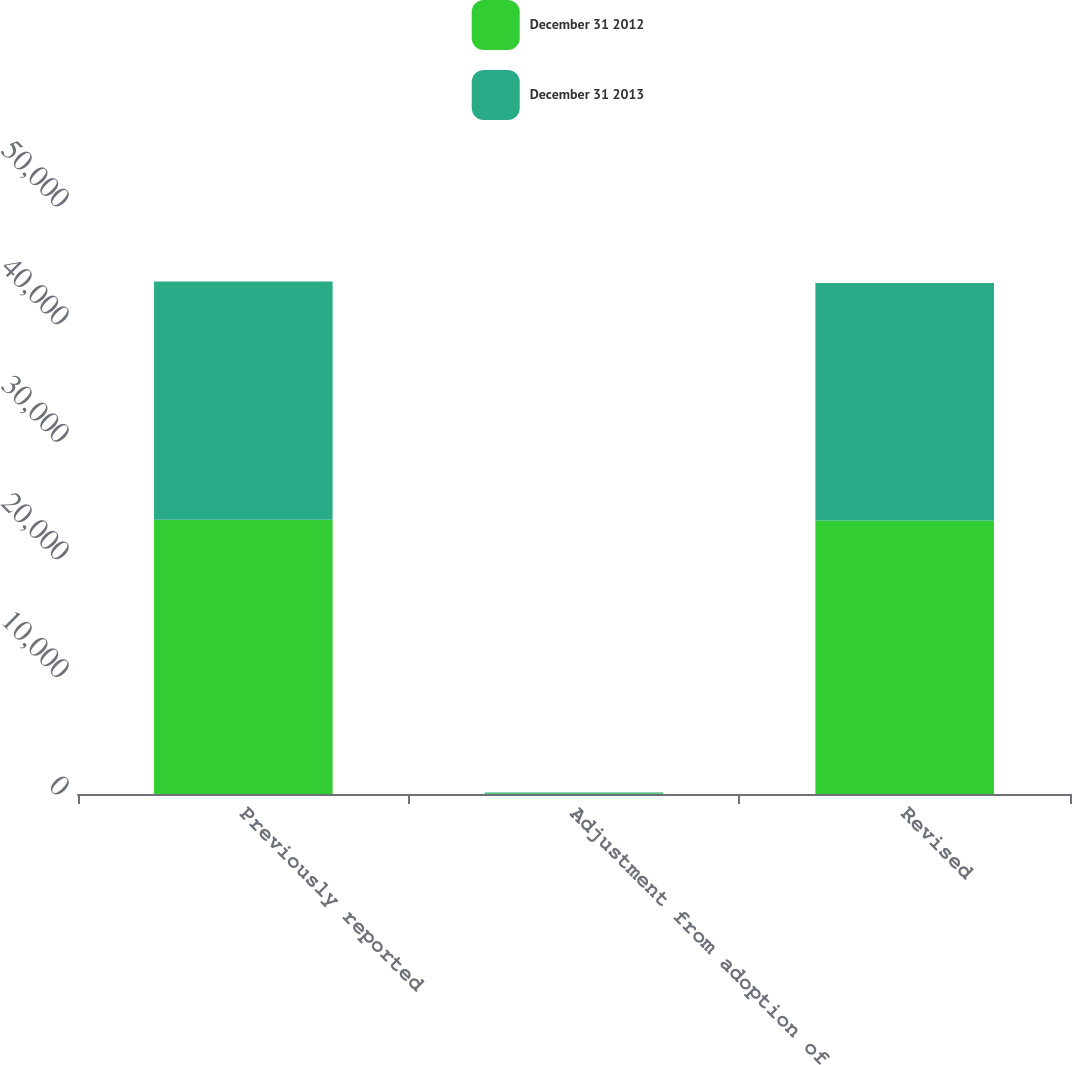Convert chart to OTSL. <chart><loc_0><loc_0><loc_500><loc_500><stacked_bar_chart><ecel><fcel>Previously reported<fcel>Adjustment from adoption of<fcel>Revised<nl><fcel>December 31 2012<fcel>23325<fcel>74<fcel>23251<nl><fcel>December 31 2013<fcel>20265<fcel>55<fcel>20210<nl></chart> 